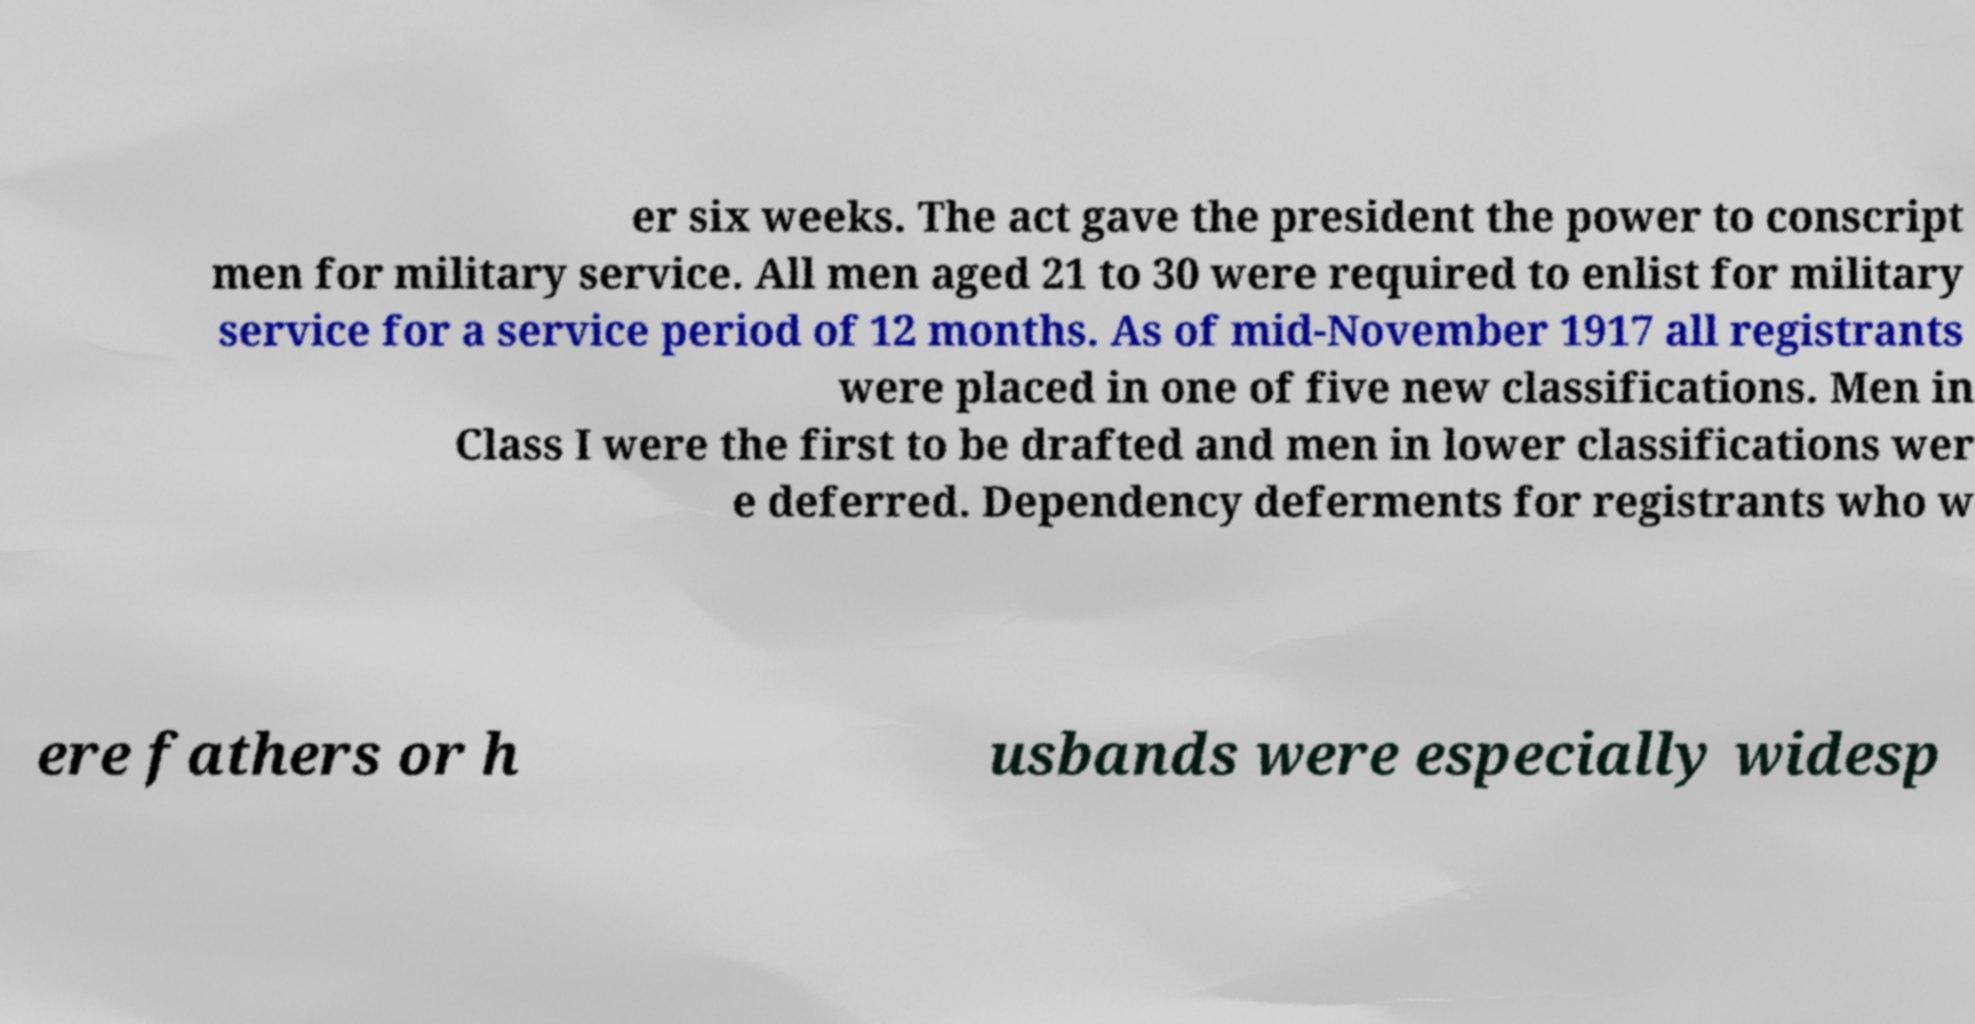For documentation purposes, I need the text within this image transcribed. Could you provide that? er six weeks. The act gave the president the power to conscript men for military service. All men aged 21 to 30 were required to enlist for military service for a service period of 12 months. As of mid-November 1917 all registrants were placed in one of five new classifications. Men in Class I were the first to be drafted and men in lower classifications wer e deferred. Dependency deferments for registrants who w ere fathers or h usbands were especially widesp 